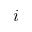<formula> <loc_0><loc_0><loc_500><loc_500>i</formula> 